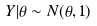<formula> <loc_0><loc_0><loc_500><loc_500>Y | \theta \sim N ( \theta , 1 )</formula> 